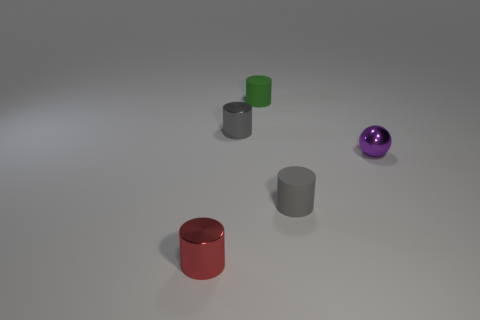Can you tell me the colors and shapes of the objects in this image? Certainly! There is a red cylindrical object, a green cube, two grey cylinders of varying sizes, and a spherical object that has a shiny, purple surface. 